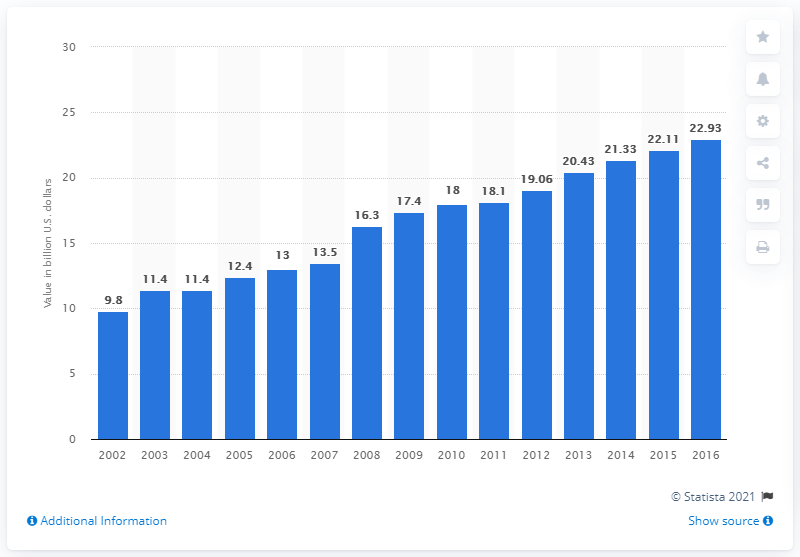Mention a couple of crucial points in this snapshot. In 2016, the value of dog and cat food in the United States was 22.93. 